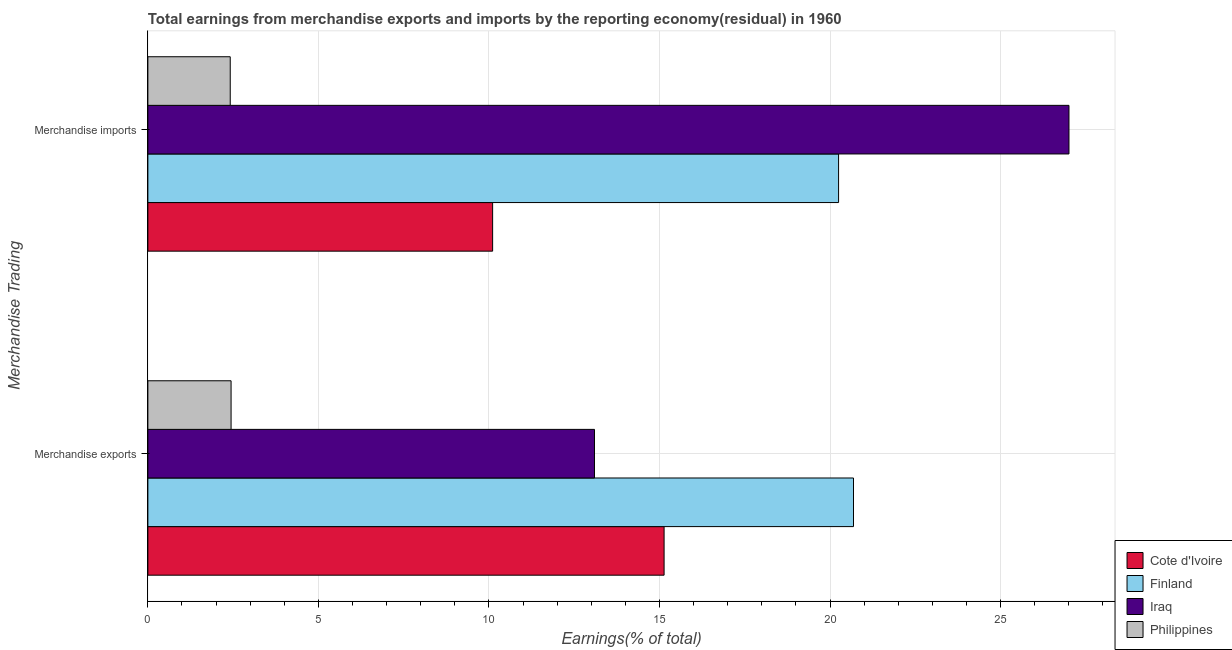How many different coloured bars are there?
Ensure brevity in your answer.  4. Are the number of bars on each tick of the Y-axis equal?
Provide a succinct answer. Yes. How many bars are there on the 1st tick from the top?
Offer a very short reply. 4. What is the label of the 2nd group of bars from the top?
Offer a terse response. Merchandise exports. What is the earnings from merchandise imports in Philippines?
Offer a very short reply. 2.41. Across all countries, what is the maximum earnings from merchandise imports?
Your answer should be very brief. 27. Across all countries, what is the minimum earnings from merchandise imports?
Your response must be concise. 2.41. In which country was the earnings from merchandise exports maximum?
Keep it short and to the point. Finland. What is the total earnings from merchandise exports in the graph?
Provide a short and direct response. 51.35. What is the difference between the earnings from merchandise exports in Philippines and that in Finland?
Your answer should be very brief. -18.25. What is the difference between the earnings from merchandise exports in Iraq and the earnings from merchandise imports in Philippines?
Ensure brevity in your answer.  10.68. What is the average earnings from merchandise imports per country?
Provide a succinct answer. 14.94. What is the difference between the earnings from merchandise imports and earnings from merchandise exports in Philippines?
Offer a terse response. -0.03. In how many countries, is the earnings from merchandise imports greater than 18 %?
Your answer should be compact. 2. What is the ratio of the earnings from merchandise imports in Cote d'Ivoire to that in Philippines?
Provide a short and direct response. 4.19. In how many countries, is the earnings from merchandise imports greater than the average earnings from merchandise imports taken over all countries?
Keep it short and to the point. 2. What does the 4th bar from the top in Merchandise exports represents?
Offer a terse response. Cote d'Ivoire. How many bars are there?
Give a very brief answer. 8. Are all the bars in the graph horizontal?
Offer a terse response. Yes. Are the values on the major ticks of X-axis written in scientific E-notation?
Make the answer very short. No. Does the graph contain any zero values?
Your answer should be compact. No. Does the graph contain grids?
Your response must be concise. Yes. Where does the legend appear in the graph?
Ensure brevity in your answer.  Bottom right. How many legend labels are there?
Offer a terse response. 4. What is the title of the graph?
Give a very brief answer. Total earnings from merchandise exports and imports by the reporting economy(residual) in 1960. What is the label or title of the X-axis?
Provide a short and direct response. Earnings(% of total). What is the label or title of the Y-axis?
Make the answer very short. Merchandise Trading. What is the Earnings(% of total) in Cote d'Ivoire in Merchandise exports?
Make the answer very short. 15.13. What is the Earnings(% of total) in Finland in Merchandise exports?
Your answer should be very brief. 20.69. What is the Earnings(% of total) in Iraq in Merchandise exports?
Make the answer very short. 13.09. What is the Earnings(% of total) in Philippines in Merchandise exports?
Your response must be concise. 2.44. What is the Earnings(% of total) of Cote d'Ivoire in Merchandise imports?
Ensure brevity in your answer.  10.11. What is the Earnings(% of total) in Finland in Merchandise imports?
Offer a terse response. 20.25. What is the Earnings(% of total) in Iraq in Merchandise imports?
Offer a terse response. 27. What is the Earnings(% of total) of Philippines in Merchandise imports?
Provide a short and direct response. 2.41. Across all Merchandise Trading, what is the maximum Earnings(% of total) of Cote d'Ivoire?
Your answer should be compact. 15.13. Across all Merchandise Trading, what is the maximum Earnings(% of total) in Finland?
Offer a terse response. 20.69. Across all Merchandise Trading, what is the maximum Earnings(% of total) in Iraq?
Provide a succinct answer. 27. Across all Merchandise Trading, what is the maximum Earnings(% of total) of Philippines?
Ensure brevity in your answer.  2.44. Across all Merchandise Trading, what is the minimum Earnings(% of total) of Cote d'Ivoire?
Your response must be concise. 10.11. Across all Merchandise Trading, what is the minimum Earnings(% of total) in Finland?
Your response must be concise. 20.25. Across all Merchandise Trading, what is the minimum Earnings(% of total) in Iraq?
Give a very brief answer. 13.09. Across all Merchandise Trading, what is the minimum Earnings(% of total) of Philippines?
Provide a short and direct response. 2.41. What is the total Earnings(% of total) of Cote d'Ivoire in the graph?
Give a very brief answer. 25.24. What is the total Earnings(% of total) of Finland in the graph?
Make the answer very short. 40.93. What is the total Earnings(% of total) of Iraq in the graph?
Provide a short and direct response. 40.1. What is the total Earnings(% of total) in Philippines in the graph?
Keep it short and to the point. 4.85. What is the difference between the Earnings(% of total) of Cote d'Ivoire in Merchandise exports and that in Merchandise imports?
Your response must be concise. 5.03. What is the difference between the Earnings(% of total) in Finland in Merchandise exports and that in Merchandise imports?
Offer a terse response. 0.44. What is the difference between the Earnings(% of total) in Iraq in Merchandise exports and that in Merchandise imports?
Ensure brevity in your answer.  -13.91. What is the difference between the Earnings(% of total) of Philippines in Merchandise exports and that in Merchandise imports?
Keep it short and to the point. 0.03. What is the difference between the Earnings(% of total) of Cote d'Ivoire in Merchandise exports and the Earnings(% of total) of Finland in Merchandise imports?
Offer a very short reply. -5.12. What is the difference between the Earnings(% of total) in Cote d'Ivoire in Merchandise exports and the Earnings(% of total) in Iraq in Merchandise imports?
Offer a very short reply. -11.87. What is the difference between the Earnings(% of total) of Cote d'Ivoire in Merchandise exports and the Earnings(% of total) of Philippines in Merchandise imports?
Provide a succinct answer. 12.72. What is the difference between the Earnings(% of total) in Finland in Merchandise exports and the Earnings(% of total) in Iraq in Merchandise imports?
Offer a terse response. -6.32. What is the difference between the Earnings(% of total) of Finland in Merchandise exports and the Earnings(% of total) of Philippines in Merchandise imports?
Give a very brief answer. 18.27. What is the difference between the Earnings(% of total) of Iraq in Merchandise exports and the Earnings(% of total) of Philippines in Merchandise imports?
Your response must be concise. 10.68. What is the average Earnings(% of total) in Cote d'Ivoire per Merchandise Trading?
Make the answer very short. 12.62. What is the average Earnings(% of total) in Finland per Merchandise Trading?
Keep it short and to the point. 20.47. What is the average Earnings(% of total) in Iraq per Merchandise Trading?
Offer a terse response. 20.05. What is the average Earnings(% of total) of Philippines per Merchandise Trading?
Your answer should be very brief. 2.43. What is the difference between the Earnings(% of total) of Cote d'Ivoire and Earnings(% of total) of Finland in Merchandise exports?
Your response must be concise. -5.55. What is the difference between the Earnings(% of total) of Cote d'Ivoire and Earnings(% of total) of Iraq in Merchandise exports?
Keep it short and to the point. 2.04. What is the difference between the Earnings(% of total) in Cote d'Ivoire and Earnings(% of total) in Philippines in Merchandise exports?
Give a very brief answer. 12.69. What is the difference between the Earnings(% of total) in Finland and Earnings(% of total) in Iraq in Merchandise exports?
Provide a succinct answer. 7.59. What is the difference between the Earnings(% of total) of Finland and Earnings(% of total) of Philippines in Merchandise exports?
Your answer should be compact. 18.25. What is the difference between the Earnings(% of total) in Iraq and Earnings(% of total) in Philippines in Merchandise exports?
Your answer should be compact. 10.65. What is the difference between the Earnings(% of total) in Cote d'Ivoire and Earnings(% of total) in Finland in Merchandise imports?
Give a very brief answer. -10.14. What is the difference between the Earnings(% of total) of Cote d'Ivoire and Earnings(% of total) of Iraq in Merchandise imports?
Your response must be concise. -16.9. What is the difference between the Earnings(% of total) of Cote d'Ivoire and Earnings(% of total) of Philippines in Merchandise imports?
Make the answer very short. 7.69. What is the difference between the Earnings(% of total) of Finland and Earnings(% of total) of Iraq in Merchandise imports?
Your answer should be very brief. -6.75. What is the difference between the Earnings(% of total) in Finland and Earnings(% of total) in Philippines in Merchandise imports?
Ensure brevity in your answer.  17.83. What is the difference between the Earnings(% of total) of Iraq and Earnings(% of total) of Philippines in Merchandise imports?
Keep it short and to the point. 24.59. What is the ratio of the Earnings(% of total) in Cote d'Ivoire in Merchandise exports to that in Merchandise imports?
Make the answer very short. 1.5. What is the ratio of the Earnings(% of total) in Finland in Merchandise exports to that in Merchandise imports?
Give a very brief answer. 1.02. What is the ratio of the Earnings(% of total) of Iraq in Merchandise exports to that in Merchandise imports?
Your answer should be very brief. 0.48. What is the ratio of the Earnings(% of total) in Philippines in Merchandise exports to that in Merchandise imports?
Keep it short and to the point. 1.01. What is the difference between the highest and the second highest Earnings(% of total) in Cote d'Ivoire?
Your answer should be compact. 5.03. What is the difference between the highest and the second highest Earnings(% of total) in Finland?
Your answer should be compact. 0.44. What is the difference between the highest and the second highest Earnings(% of total) of Iraq?
Offer a terse response. 13.91. What is the difference between the highest and the second highest Earnings(% of total) of Philippines?
Ensure brevity in your answer.  0.03. What is the difference between the highest and the lowest Earnings(% of total) of Cote d'Ivoire?
Your response must be concise. 5.03. What is the difference between the highest and the lowest Earnings(% of total) of Finland?
Offer a terse response. 0.44. What is the difference between the highest and the lowest Earnings(% of total) of Iraq?
Provide a short and direct response. 13.91. What is the difference between the highest and the lowest Earnings(% of total) in Philippines?
Ensure brevity in your answer.  0.03. 